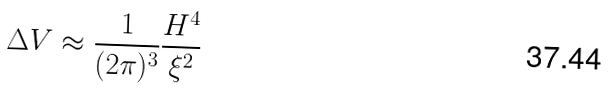Convert formula to latex. <formula><loc_0><loc_0><loc_500><loc_500>\Delta V \approx \frac { 1 } { ( 2 \pi ) ^ { 3 } } \frac { H ^ { 4 } } { \xi ^ { 2 } }</formula> 